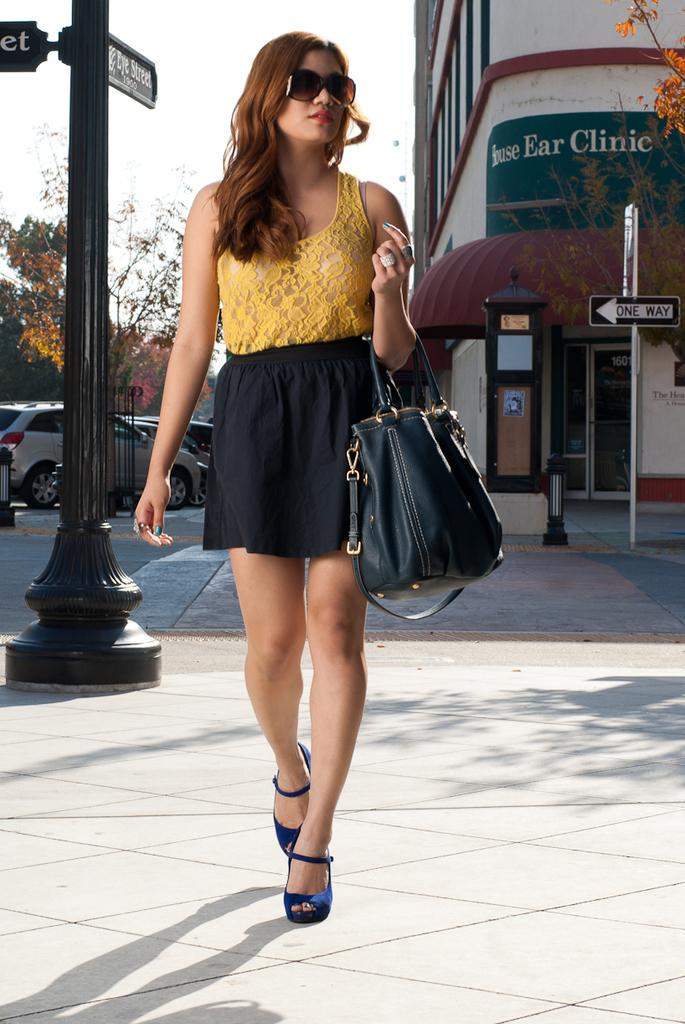What is the main subject of the image? There is a woman standing in the center of the image. What is the woman holding in her hand? The woman is holding a bag in her hand. What can be seen in the background on the right side of the image? There is a building in the background on the right side of the image. What else can be seen in the background on the left side of the image? There are cars visible in the background on the left side of the image. What type of cat can be seen sitting on the woman's neck in the image? There is no cat present in the image, and the woman's neck is not visible. 